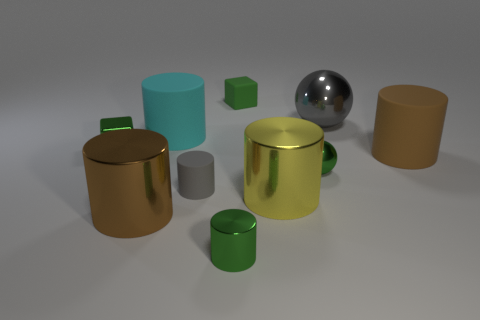Subtract all green cylinders. How many cylinders are left? 5 Subtract all small green cylinders. How many cylinders are left? 5 Subtract all blue cylinders. Subtract all red balls. How many cylinders are left? 6 Subtract all cubes. How many objects are left? 8 Subtract 0 yellow spheres. How many objects are left? 10 Subtract all big metal spheres. Subtract all big metal spheres. How many objects are left? 8 Add 3 large cyan rubber objects. How many large cyan rubber objects are left? 4 Add 6 small shiny spheres. How many small shiny spheres exist? 7 